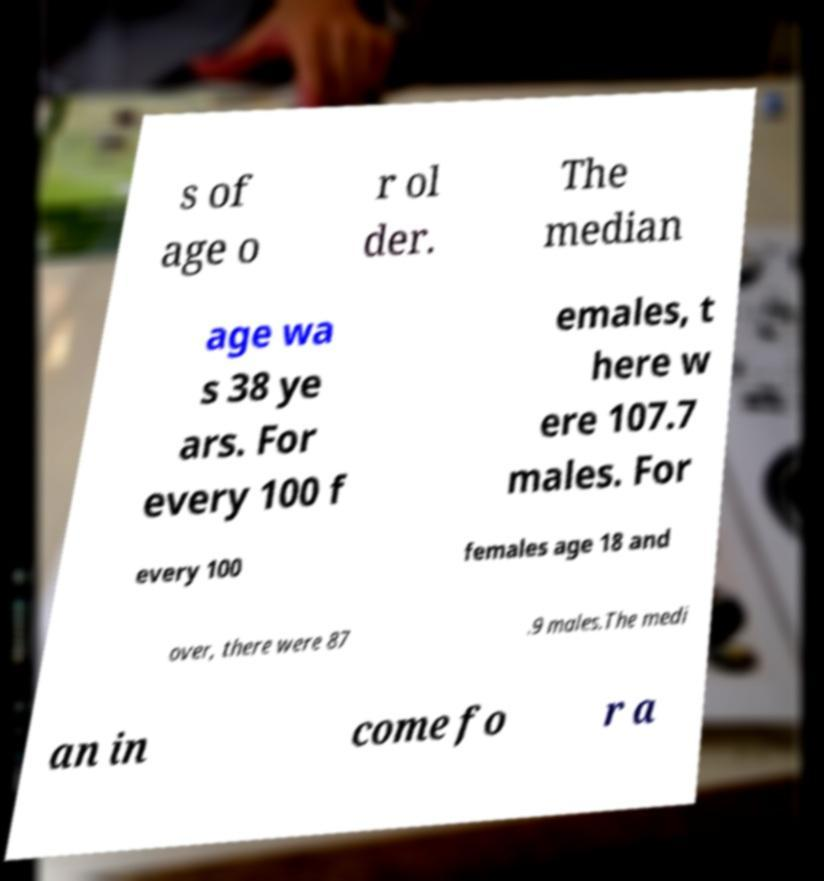Can you accurately transcribe the text from the provided image for me? s of age o r ol der. The median age wa s 38 ye ars. For every 100 f emales, t here w ere 107.7 males. For every 100 females age 18 and over, there were 87 .9 males.The medi an in come fo r a 